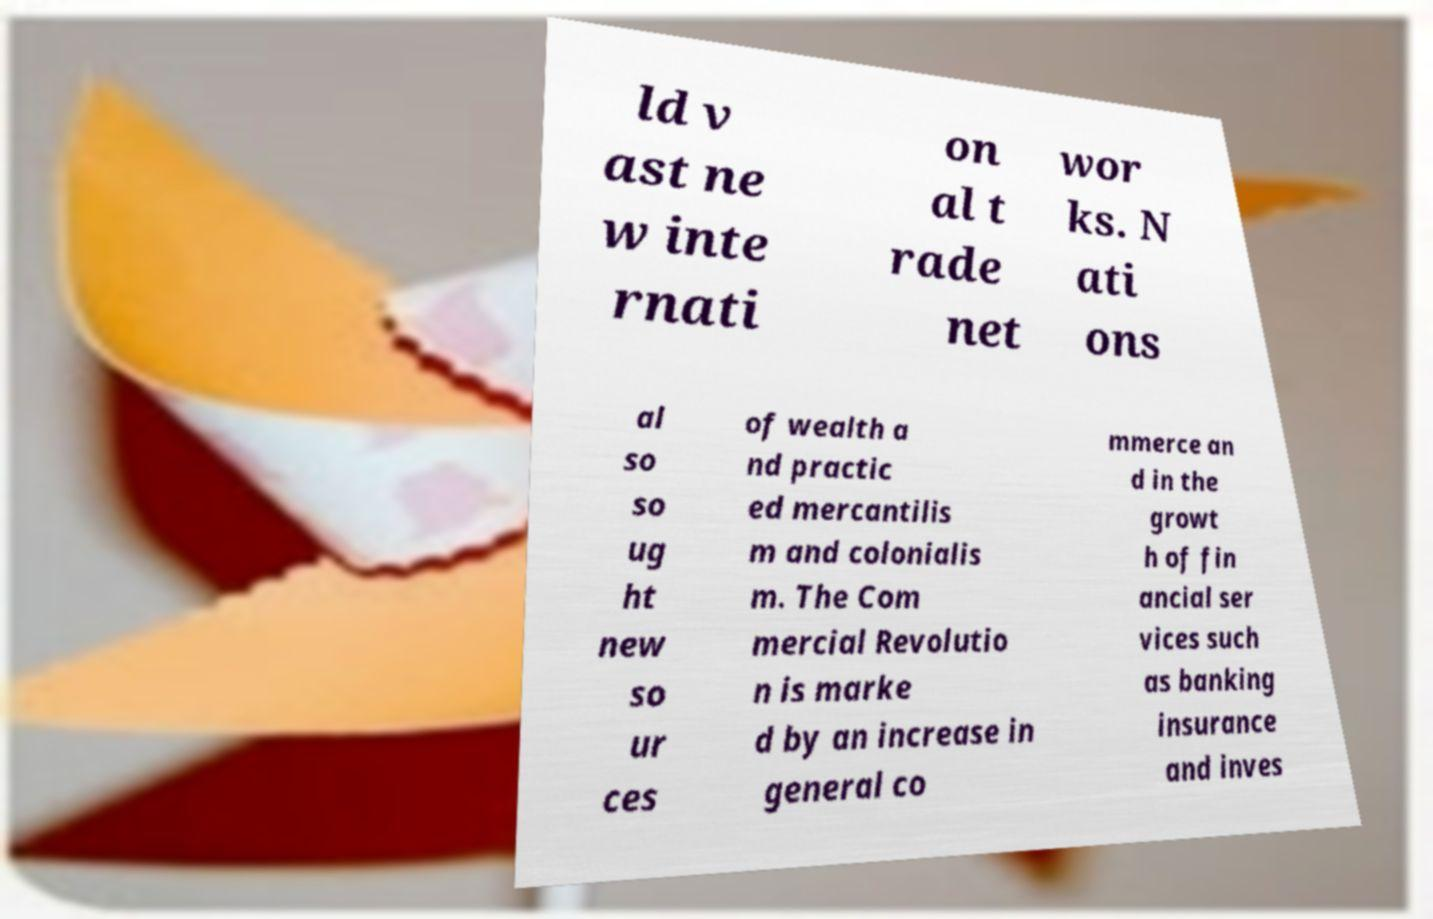Could you extract and type out the text from this image? ld v ast ne w inte rnati on al t rade net wor ks. N ati ons al so so ug ht new so ur ces of wealth a nd practic ed mercantilis m and colonialis m. The Com mercial Revolutio n is marke d by an increase in general co mmerce an d in the growt h of fin ancial ser vices such as banking insurance and inves 